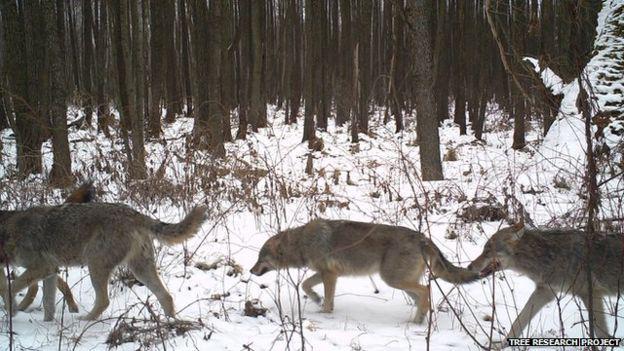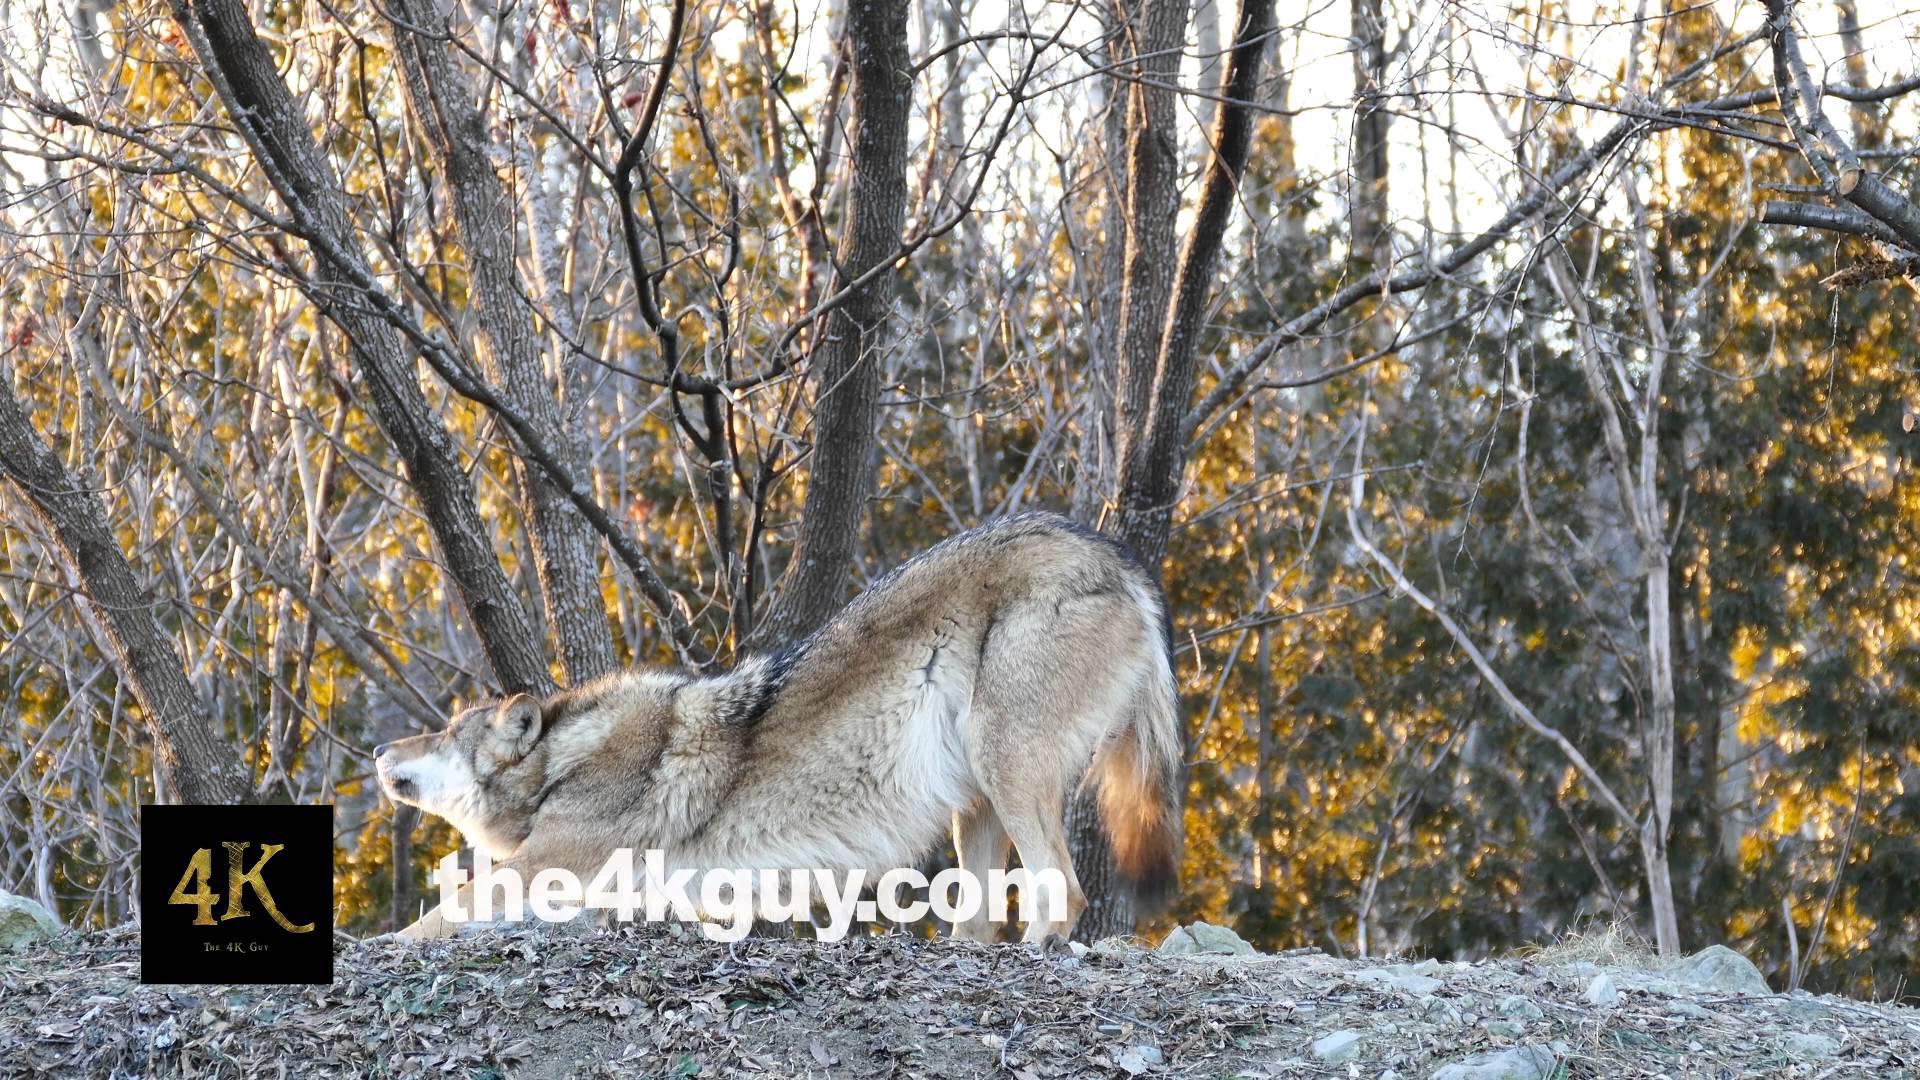The first image is the image on the left, the second image is the image on the right. Assess this claim about the two images: "The right image contains exactly one wolf.". Correct or not? Answer yes or no. Yes. The first image is the image on the left, the second image is the image on the right. Evaluate the accuracy of this statement regarding the images: "Wolves are walking leftward in a straight line across snow-covered ground in one image.". Is it true? Answer yes or no. Yes. 